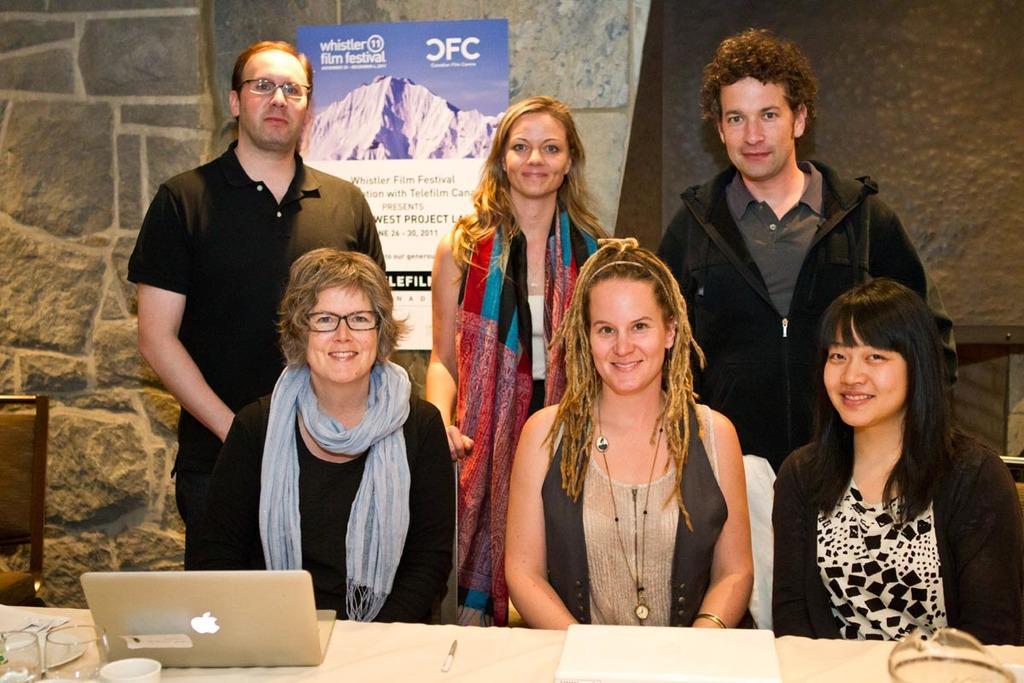Could you give a brief overview of what you see in this image? In the picture I can see three people are sitting on chairs in front of a table and three people are standing in the background. These people are smiling. On the table I can see a laptop, shades, papers and some other objects. In the background I can see a board attached to the wall. 